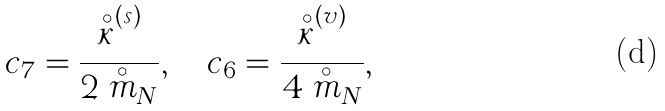<formula> <loc_0><loc_0><loc_500><loc_500>c _ { 7 } = \frac { \stackrel { \circ } { \kappa } ^ { ( s ) } } { 2 \stackrel { \circ } { m } _ { N } } , \quad c _ { 6 } = \frac { \stackrel { \circ } { \kappa } ^ { ( v ) } } { 4 \stackrel { \circ } { m } _ { N } } ,</formula> 